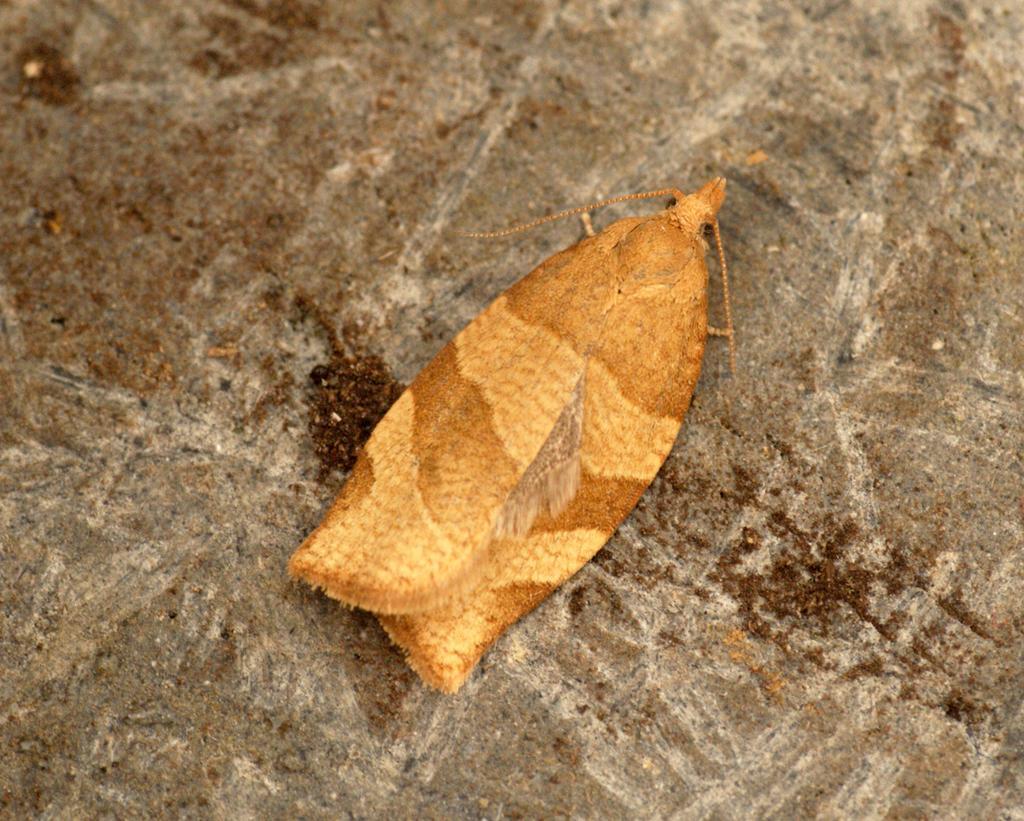Please provide a concise description of this image. This image consists of a fly in brown color. It is on the ground. At the bottom, there is a ground. 